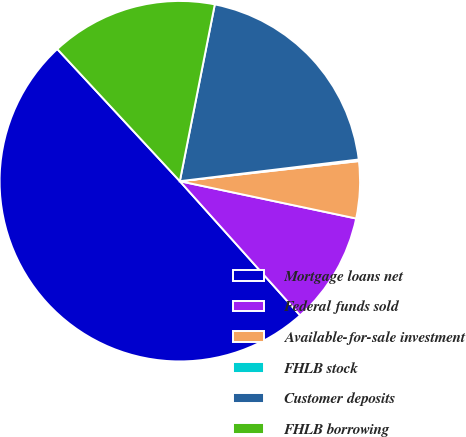<chart> <loc_0><loc_0><loc_500><loc_500><pie_chart><fcel>Mortgage loans net<fcel>Federal funds sold<fcel>Available-for-sale investment<fcel>FHLB stock<fcel>Customer deposits<fcel>FHLB borrowing<nl><fcel>49.73%<fcel>10.05%<fcel>5.1%<fcel>0.14%<fcel>19.97%<fcel>15.01%<nl></chart> 